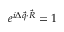Convert formula to latex. <formula><loc_0><loc_0><loc_500><loc_500>e ^ { i \Delta \vec { q } \cdot \vec { R } } = 1</formula> 